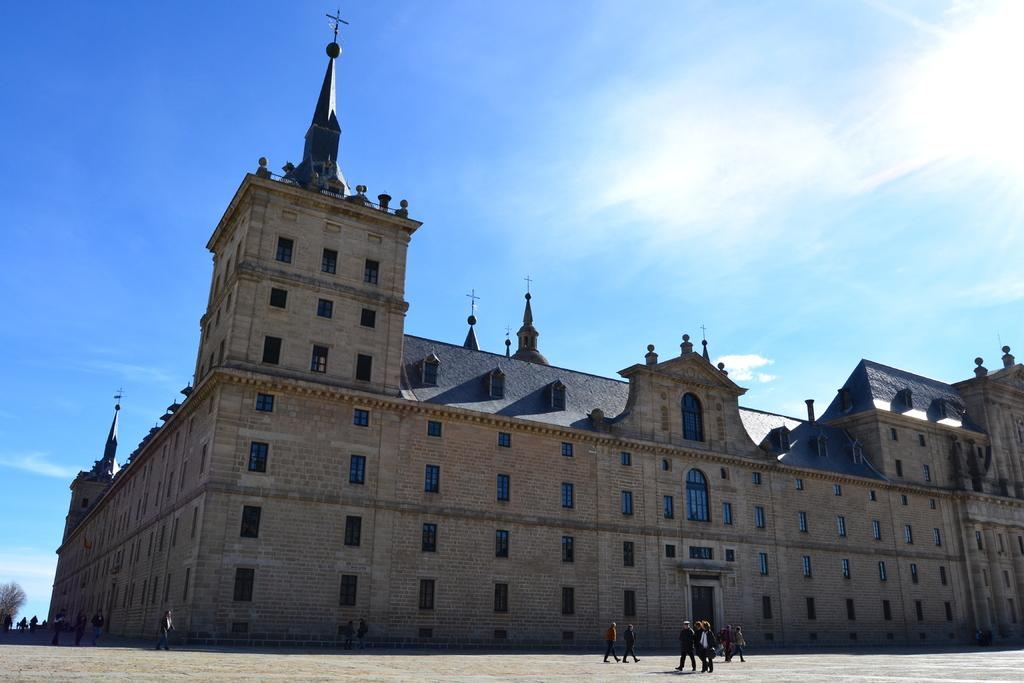What is the main subject in the center of the image? There is a building in the center of the image. What can be seen happening in front of the building? There are people walking on the road in front of the building. What type of natural elements are visible in the background of the image? There are trees in the background of the image. What part of the sky is visible in the image? The sky is visible in the background of the image. What type of quilt is being used to cover the building in the image? There is no quilt present in the image, and the building is not covered by any quilt. How many days of the week are visible in the image? The concept of days of the week is not relevant to the image, as it only shows a building, people walking, trees, and the sky. 